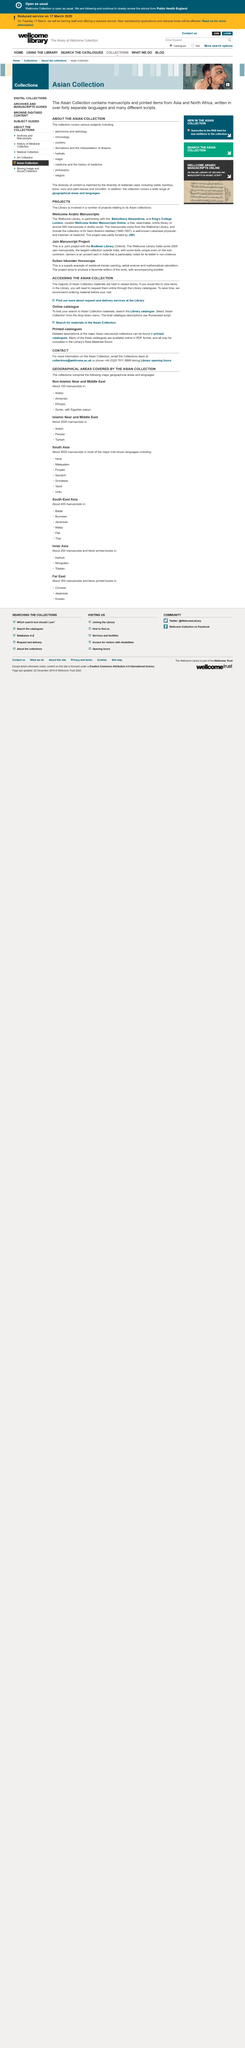Highlight a few significant elements in this photo. Dr. Sami Ibrahim Haddad lived from 1890 to 1957. The project was partially funded by JISC. The Wellcome Library has partnered with the Bibliotheca Alexandrina and King's College London. 